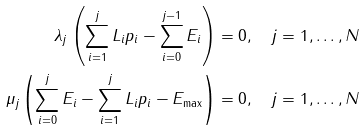Convert formula to latex. <formula><loc_0><loc_0><loc_500><loc_500>\lambda _ { j } \left ( \sum _ { i = 1 } ^ { j } L _ { i } p _ { i } - \sum _ { i = 0 } ^ { j - 1 } E _ { i } \right ) & = 0 , \quad j = 1 , \dots , N \\ \mu _ { j } \left ( \sum _ { i = 0 } ^ { j } E _ { i } - \sum _ { i = 1 } ^ { j } L _ { i } p _ { i } - E _ { \max } \right ) & = 0 , \quad j = 1 , \dots , N</formula> 